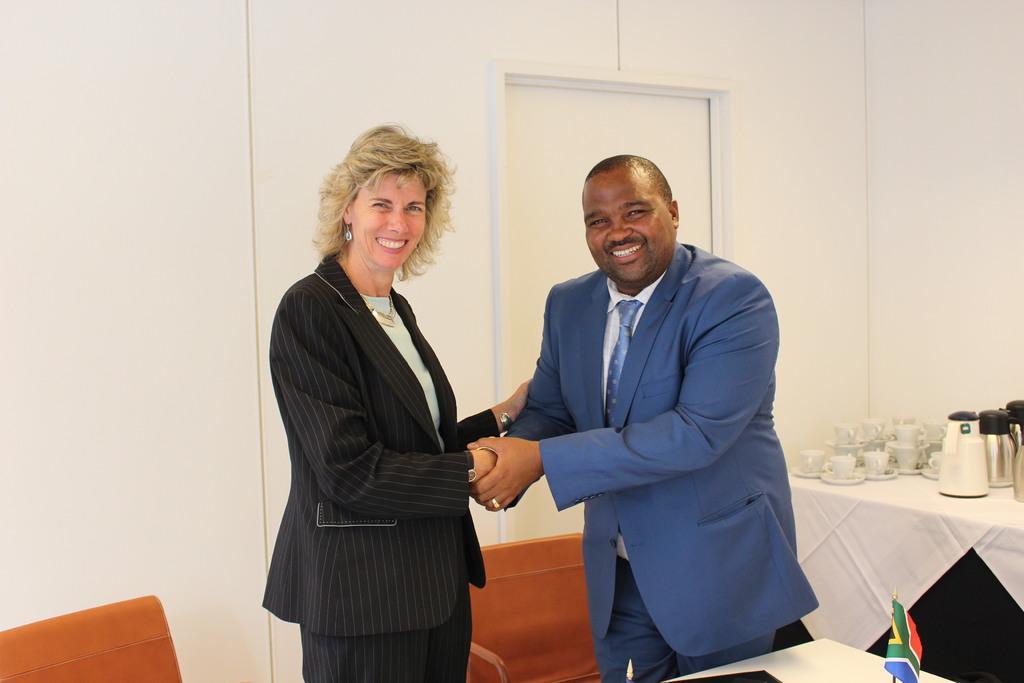Describe this image in one or two sentences. In the image in the center, we can see two persons are standing and they are smiling, which we can see on their faces. And we can see chairs and tables. On the tables, we can see one flag, one cloth, flasks, cups, saucers and a few other objects. In the background there is a wall and door. 